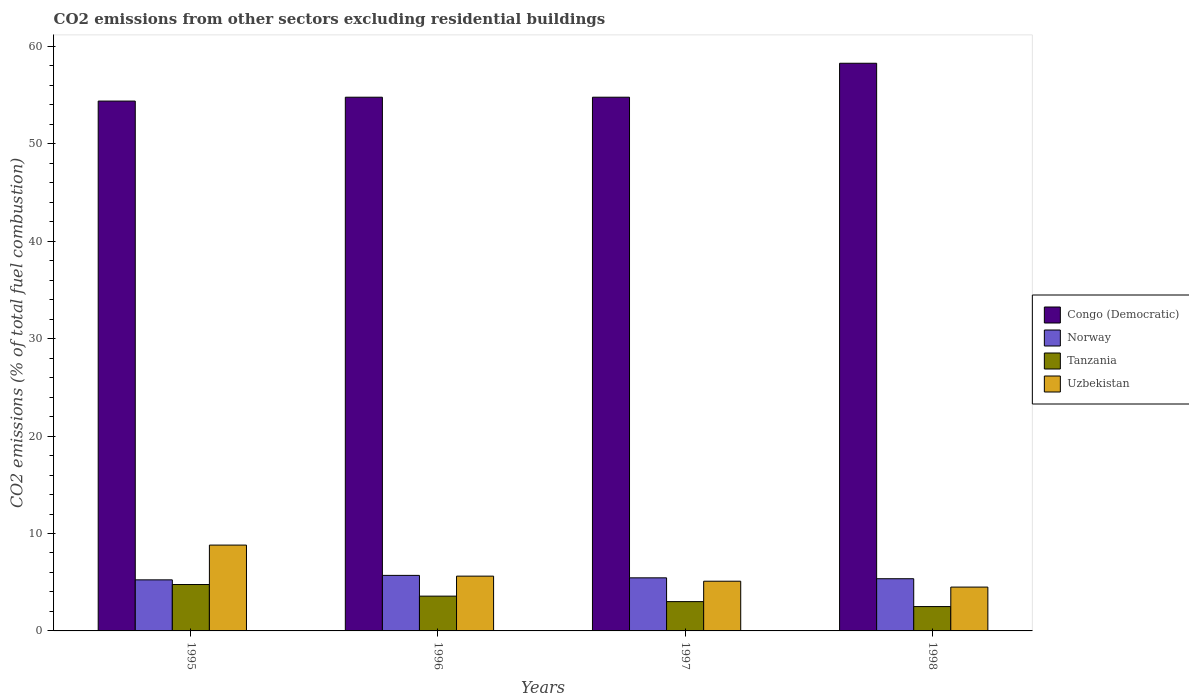How many different coloured bars are there?
Give a very brief answer. 4. How many groups of bars are there?
Give a very brief answer. 4. Are the number of bars per tick equal to the number of legend labels?
Make the answer very short. Yes. Are the number of bars on each tick of the X-axis equal?
Your answer should be compact. Yes. In how many cases, is the number of bars for a given year not equal to the number of legend labels?
Keep it short and to the point. 0. Across all years, what is the maximum total CO2 emitted in Congo (Democratic)?
Your answer should be very brief. 58.27. Across all years, what is the minimum total CO2 emitted in Congo (Democratic)?
Your response must be concise. 54.39. In which year was the total CO2 emitted in Norway minimum?
Make the answer very short. 1995. What is the total total CO2 emitted in Uzbekistan in the graph?
Offer a very short reply. 24.04. What is the difference between the total CO2 emitted in Congo (Democratic) in 1996 and that in 1998?
Offer a terse response. -3.49. What is the difference between the total CO2 emitted in Norway in 1997 and the total CO2 emitted in Uzbekistan in 1995?
Offer a very short reply. -3.36. What is the average total CO2 emitted in Tanzania per year?
Keep it short and to the point. 3.46. In the year 1995, what is the difference between the total CO2 emitted in Uzbekistan and total CO2 emitted in Norway?
Your answer should be very brief. 3.57. What is the ratio of the total CO2 emitted in Norway in 1995 to that in 1996?
Keep it short and to the point. 0.92. Is the total CO2 emitted in Norway in 1995 less than that in 1997?
Make the answer very short. Yes. Is the difference between the total CO2 emitted in Uzbekistan in 1996 and 1997 greater than the difference between the total CO2 emitted in Norway in 1996 and 1997?
Make the answer very short. Yes. What is the difference between the highest and the second highest total CO2 emitted in Tanzania?
Provide a succinct answer. 1.19. What is the difference between the highest and the lowest total CO2 emitted in Tanzania?
Provide a succinct answer. 2.26. In how many years, is the total CO2 emitted in Uzbekistan greater than the average total CO2 emitted in Uzbekistan taken over all years?
Keep it short and to the point. 1. What does the 4th bar from the left in 1997 represents?
Your response must be concise. Uzbekistan. What does the 1st bar from the right in 1998 represents?
Your response must be concise. Uzbekistan. How many bars are there?
Your answer should be very brief. 16. How many years are there in the graph?
Ensure brevity in your answer.  4. What is the difference between two consecutive major ticks on the Y-axis?
Keep it short and to the point. 10. Does the graph contain grids?
Give a very brief answer. No. How are the legend labels stacked?
Your answer should be very brief. Vertical. What is the title of the graph?
Offer a terse response. CO2 emissions from other sectors excluding residential buildings. Does "Comoros" appear as one of the legend labels in the graph?
Your response must be concise. No. What is the label or title of the X-axis?
Provide a succinct answer. Years. What is the label or title of the Y-axis?
Ensure brevity in your answer.  CO2 emissions (% of total fuel combustion). What is the CO2 emissions (% of total fuel combustion) of Congo (Democratic) in 1995?
Provide a succinct answer. 54.39. What is the CO2 emissions (% of total fuel combustion) in Norway in 1995?
Offer a terse response. 5.24. What is the CO2 emissions (% of total fuel combustion) in Tanzania in 1995?
Make the answer very short. 4.76. What is the CO2 emissions (% of total fuel combustion) of Uzbekistan in 1995?
Give a very brief answer. 8.81. What is the CO2 emissions (% of total fuel combustion) in Congo (Democratic) in 1996?
Ensure brevity in your answer.  54.78. What is the CO2 emissions (% of total fuel combustion) in Norway in 1996?
Make the answer very short. 5.7. What is the CO2 emissions (% of total fuel combustion) in Tanzania in 1996?
Provide a succinct answer. 3.57. What is the CO2 emissions (% of total fuel combustion) in Uzbekistan in 1996?
Your answer should be compact. 5.62. What is the CO2 emissions (% of total fuel combustion) in Congo (Democratic) in 1997?
Provide a succinct answer. 54.78. What is the CO2 emissions (% of total fuel combustion) in Norway in 1997?
Ensure brevity in your answer.  5.45. What is the CO2 emissions (% of total fuel combustion) in Tanzania in 1997?
Your response must be concise. 3.01. What is the CO2 emissions (% of total fuel combustion) in Uzbekistan in 1997?
Keep it short and to the point. 5.1. What is the CO2 emissions (% of total fuel combustion) of Congo (Democratic) in 1998?
Provide a succinct answer. 58.27. What is the CO2 emissions (% of total fuel combustion) of Norway in 1998?
Provide a short and direct response. 5.36. What is the CO2 emissions (% of total fuel combustion) in Tanzania in 1998?
Offer a very short reply. 2.5. What is the CO2 emissions (% of total fuel combustion) in Uzbekistan in 1998?
Your response must be concise. 4.5. Across all years, what is the maximum CO2 emissions (% of total fuel combustion) of Congo (Democratic)?
Give a very brief answer. 58.27. Across all years, what is the maximum CO2 emissions (% of total fuel combustion) in Norway?
Offer a terse response. 5.7. Across all years, what is the maximum CO2 emissions (% of total fuel combustion) of Tanzania?
Your answer should be compact. 4.76. Across all years, what is the maximum CO2 emissions (% of total fuel combustion) in Uzbekistan?
Your answer should be very brief. 8.81. Across all years, what is the minimum CO2 emissions (% of total fuel combustion) of Congo (Democratic)?
Offer a terse response. 54.39. Across all years, what is the minimum CO2 emissions (% of total fuel combustion) in Norway?
Keep it short and to the point. 5.24. Across all years, what is the minimum CO2 emissions (% of total fuel combustion) in Uzbekistan?
Offer a terse response. 4.5. What is the total CO2 emissions (% of total fuel combustion) of Congo (Democratic) in the graph?
Provide a short and direct response. 222.22. What is the total CO2 emissions (% of total fuel combustion) of Norway in the graph?
Make the answer very short. 21.75. What is the total CO2 emissions (% of total fuel combustion) of Tanzania in the graph?
Make the answer very short. 13.84. What is the total CO2 emissions (% of total fuel combustion) of Uzbekistan in the graph?
Make the answer very short. 24.04. What is the difference between the CO2 emissions (% of total fuel combustion) in Congo (Democratic) in 1995 and that in 1996?
Keep it short and to the point. -0.4. What is the difference between the CO2 emissions (% of total fuel combustion) in Norway in 1995 and that in 1996?
Keep it short and to the point. -0.46. What is the difference between the CO2 emissions (% of total fuel combustion) of Tanzania in 1995 and that in 1996?
Provide a short and direct response. 1.19. What is the difference between the CO2 emissions (% of total fuel combustion) in Uzbekistan in 1995 and that in 1996?
Make the answer very short. 3.19. What is the difference between the CO2 emissions (% of total fuel combustion) in Congo (Democratic) in 1995 and that in 1997?
Give a very brief answer. -0.4. What is the difference between the CO2 emissions (% of total fuel combustion) in Norway in 1995 and that in 1997?
Give a very brief answer. -0.21. What is the difference between the CO2 emissions (% of total fuel combustion) in Tanzania in 1995 and that in 1997?
Your response must be concise. 1.75. What is the difference between the CO2 emissions (% of total fuel combustion) of Uzbekistan in 1995 and that in 1997?
Ensure brevity in your answer.  3.71. What is the difference between the CO2 emissions (% of total fuel combustion) of Congo (Democratic) in 1995 and that in 1998?
Ensure brevity in your answer.  -3.88. What is the difference between the CO2 emissions (% of total fuel combustion) in Norway in 1995 and that in 1998?
Ensure brevity in your answer.  -0.11. What is the difference between the CO2 emissions (% of total fuel combustion) of Tanzania in 1995 and that in 1998?
Your response must be concise. 2.26. What is the difference between the CO2 emissions (% of total fuel combustion) of Uzbekistan in 1995 and that in 1998?
Offer a terse response. 4.31. What is the difference between the CO2 emissions (% of total fuel combustion) of Norway in 1996 and that in 1997?
Provide a short and direct response. 0.25. What is the difference between the CO2 emissions (% of total fuel combustion) in Tanzania in 1996 and that in 1997?
Provide a succinct answer. 0.56. What is the difference between the CO2 emissions (% of total fuel combustion) of Uzbekistan in 1996 and that in 1997?
Offer a terse response. 0.52. What is the difference between the CO2 emissions (% of total fuel combustion) in Congo (Democratic) in 1996 and that in 1998?
Give a very brief answer. -3.49. What is the difference between the CO2 emissions (% of total fuel combustion) in Norway in 1996 and that in 1998?
Your answer should be very brief. 0.34. What is the difference between the CO2 emissions (% of total fuel combustion) of Tanzania in 1996 and that in 1998?
Provide a succinct answer. 1.07. What is the difference between the CO2 emissions (% of total fuel combustion) of Uzbekistan in 1996 and that in 1998?
Your answer should be compact. 1.12. What is the difference between the CO2 emissions (% of total fuel combustion) of Congo (Democratic) in 1997 and that in 1998?
Make the answer very short. -3.49. What is the difference between the CO2 emissions (% of total fuel combustion) in Norway in 1997 and that in 1998?
Make the answer very short. 0.09. What is the difference between the CO2 emissions (% of total fuel combustion) in Tanzania in 1997 and that in 1998?
Ensure brevity in your answer.  0.51. What is the difference between the CO2 emissions (% of total fuel combustion) in Uzbekistan in 1997 and that in 1998?
Offer a terse response. 0.6. What is the difference between the CO2 emissions (% of total fuel combustion) in Congo (Democratic) in 1995 and the CO2 emissions (% of total fuel combustion) in Norway in 1996?
Keep it short and to the point. 48.68. What is the difference between the CO2 emissions (% of total fuel combustion) in Congo (Democratic) in 1995 and the CO2 emissions (% of total fuel combustion) in Tanzania in 1996?
Your answer should be very brief. 50.81. What is the difference between the CO2 emissions (% of total fuel combustion) in Congo (Democratic) in 1995 and the CO2 emissions (% of total fuel combustion) in Uzbekistan in 1996?
Provide a short and direct response. 48.76. What is the difference between the CO2 emissions (% of total fuel combustion) in Norway in 1995 and the CO2 emissions (% of total fuel combustion) in Tanzania in 1996?
Provide a short and direct response. 1.67. What is the difference between the CO2 emissions (% of total fuel combustion) in Norway in 1995 and the CO2 emissions (% of total fuel combustion) in Uzbekistan in 1996?
Your response must be concise. -0.38. What is the difference between the CO2 emissions (% of total fuel combustion) in Tanzania in 1995 and the CO2 emissions (% of total fuel combustion) in Uzbekistan in 1996?
Your answer should be compact. -0.86. What is the difference between the CO2 emissions (% of total fuel combustion) in Congo (Democratic) in 1995 and the CO2 emissions (% of total fuel combustion) in Norway in 1997?
Make the answer very short. 48.94. What is the difference between the CO2 emissions (% of total fuel combustion) in Congo (Democratic) in 1995 and the CO2 emissions (% of total fuel combustion) in Tanzania in 1997?
Offer a terse response. 51.38. What is the difference between the CO2 emissions (% of total fuel combustion) of Congo (Democratic) in 1995 and the CO2 emissions (% of total fuel combustion) of Uzbekistan in 1997?
Provide a succinct answer. 49.28. What is the difference between the CO2 emissions (% of total fuel combustion) in Norway in 1995 and the CO2 emissions (% of total fuel combustion) in Tanzania in 1997?
Provide a short and direct response. 2.23. What is the difference between the CO2 emissions (% of total fuel combustion) of Norway in 1995 and the CO2 emissions (% of total fuel combustion) of Uzbekistan in 1997?
Your answer should be very brief. 0.14. What is the difference between the CO2 emissions (% of total fuel combustion) of Tanzania in 1995 and the CO2 emissions (% of total fuel combustion) of Uzbekistan in 1997?
Ensure brevity in your answer.  -0.34. What is the difference between the CO2 emissions (% of total fuel combustion) in Congo (Democratic) in 1995 and the CO2 emissions (% of total fuel combustion) in Norway in 1998?
Keep it short and to the point. 49.03. What is the difference between the CO2 emissions (% of total fuel combustion) in Congo (Democratic) in 1995 and the CO2 emissions (% of total fuel combustion) in Tanzania in 1998?
Offer a terse response. 51.89. What is the difference between the CO2 emissions (% of total fuel combustion) of Congo (Democratic) in 1995 and the CO2 emissions (% of total fuel combustion) of Uzbekistan in 1998?
Ensure brevity in your answer.  49.89. What is the difference between the CO2 emissions (% of total fuel combustion) in Norway in 1995 and the CO2 emissions (% of total fuel combustion) in Tanzania in 1998?
Your answer should be compact. 2.74. What is the difference between the CO2 emissions (% of total fuel combustion) of Norway in 1995 and the CO2 emissions (% of total fuel combustion) of Uzbekistan in 1998?
Make the answer very short. 0.74. What is the difference between the CO2 emissions (% of total fuel combustion) in Tanzania in 1995 and the CO2 emissions (% of total fuel combustion) in Uzbekistan in 1998?
Your answer should be compact. 0.26. What is the difference between the CO2 emissions (% of total fuel combustion) of Congo (Democratic) in 1996 and the CO2 emissions (% of total fuel combustion) of Norway in 1997?
Provide a succinct answer. 49.33. What is the difference between the CO2 emissions (% of total fuel combustion) in Congo (Democratic) in 1996 and the CO2 emissions (% of total fuel combustion) in Tanzania in 1997?
Provide a succinct answer. 51.78. What is the difference between the CO2 emissions (% of total fuel combustion) in Congo (Democratic) in 1996 and the CO2 emissions (% of total fuel combustion) in Uzbekistan in 1997?
Ensure brevity in your answer.  49.68. What is the difference between the CO2 emissions (% of total fuel combustion) in Norway in 1996 and the CO2 emissions (% of total fuel combustion) in Tanzania in 1997?
Give a very brief answer. 2.69. What is the difference between the CO2 emissions (% of total fuel combustion) of Norway in 1996 and the CO2 emissions (% of total fuel combustion) of Uzbekistan in 1997?
Keep it short and to the point. 0.6. What is the difference between the CO2 emissions (% of total fuel combustion) of Tanzania in 1996 and the CO2 emissions (% of total fuel combustion) of Uzbekistan in 1997?
Your answer should be very brief. -1.53. What is the difference between the CO2 emissions (% of total fuel combustion) in Congo (Democratic) in 1996 and the CO2 emissions (% of total fuel combustion) in Norway in 1998?
Your answer should be very brief. 49.43. What is the difference between the CO2 emissions (% of total fuel combustion) in Congo (Democratic) in 1996 and the CO2 emissions (% of total fuel combustion) in Tanzania in 1998?
Make the answer very short. 52.28. What is the difference between the CO2 emissions (% of total fuel combustion) in Congo (Democratic) in 1996 and the CO2 emissions (% of total fuel combustion) in Uzbekistan in 1998?
Make the answer very short. 50.28. What is the difference between the CO2 emissions (% of total fuel combustion) in Norway in 1996 and the CO2 emissions (% of total fuel combustion) in Tanzania in 1998?
Your response must be concise. 3.2. What is the difference between the CO2 emissions (% of total fuel combustion) of Norway in 1996 and the CO2 emissions (% of total fuel combustion) of Uzbekistan in 1998?
Offer a very short reply. 1.2. What is the difference between the CO2 emissions (% of total fuel combustion) of Tanzania in 1996 and the CO2 emissions (% of total fuel combustion) of Uzbekistan in 1998?
Your answer should be very brief. -0.93. What is the difference between the CO2 emissions (% of total fuel combustion) in Congo (Democratic) in 1997 and the CO2 emissions (% of total fuel combustion) in Norway in 1998?
Offer a terse response. 49.43. What is the difference between the CO2 emissions (% of total fuel combustion) of Congo (Democratic) in 1997 and the CO2 emissions (% of total fuel combustion) of Tanzania in 1998?
Offer a very short reply. 52.28. What is the difference between the CO2 emissions (% of total fuel combustion) of Congo (Democratic) in 1997 and the CO2 emissions (% of total fuel combustion) of Uzbekistan in 1998?
Keep it short and to the point. 50.28. What is the difference between the CO2 emissions (% of total fuel combustion) of Norway in 1997 and the CO2 emissions (% of total fuel combustion) of Tanzania in 1998?
Provide a succinct answer. 2.95. What is the difference between the CO2 emissions (% of total fuel combustion) of Norway in 1997 and the CO2 emissions (% of total fuel combustion) of Uzbekistan in 1998?
Provide a succinct answer. 0.95. What is the difference between the CO2 emissions (% of total fuel combustion) of Tanzania in 1997 and the CO2 emissions (% of total fuel combustion) of Uzbekistan in 1998?
Your answer should be compact. -1.49. What is the average CO2 emissions (% of total fuel combustion) of Congo (Democratic) per year?
Ensure brevity in your answer.  55.55. What is the average CO2 emissions (% of total fuel combustion) of Norway per year?
Provide a succinct answer. 5.44. What is the average CO2 emissions (% of total fuel combustion) in Tanzania per year?
Give a very brief answer. 3.46. What is the average CO2 emissions (% of total fuel combustion) in Uzbekistan per year?
Your answer should be compact. 6.01. In the year 1995, what is the difference between the CO2 emissions (% of total fuel combustion) in Congo (Democratic) and CO2 emissions (% of total fuel combustion) in Norway?
Give a very brief answer. 49.14. In the year 1995, what is the difference between the CO2 emissions (% of total fuel combustion) of Congo (Democratic) and CO2 emissions (% of total fuel combustion) of Tanzania?
Ensure brevity in your answer.  49.62. In the year 1995, what is the difference between the CO2 emissions (% of total fuel combustion) of Congo (Democratic) and CO2 emissions (% of total fuel combustion) of Uzbekistan?
Ensure brevity in your answer.  45.58. In the year 1995, what is the difference between the CO2 emissions (% of total fuel combustion) in Norway and CO2 emissions (% of total fuel combustion) in Tanzania?
Give a very brief answer. 0.48. In the year 1995, what is the difference between the CO2 emissions (% of total fuel combustion) of Norway and CO2 emissions (% of total fuel combustion) of Uzbekistan?
Your answer should be compact. -3.57. In the year 1995, what is the difference between the CO2 emissions (% of total fuel combustion) in Tanzania and CO2 emissions (% of total fuel combustion) in Uzbekistan?
Provide a succinct answer. -4.05. In the year 1996, what is the difference between the CO2 emissions (% of total fuel combustion) of Congo (Democratic) and CO2 emissions (% of total fuel combustion) of Norway?
Offer a terse response. 49.08. In the year 1996, what is the difference between the CO2 emissions (% of total fuel combustion) in Congo (Democratic) and CO2 emissions (% of total fuel combustion) in Tanzania?
Provide a succinct answer. 51.21. In the year 1996, what is the difference between the CO2 emissions (% of total fuel combustion) in Congo (Democratic) and CO2 emissions (% of total fuel combustion) in Uzbekistan?
Keep it short and to the point. 49.16. In the year 1996, what is the difference between the CO2 emissions (% of total fuel combustion) of Norway and CO2 emissions (% of total fuel combustion) of Tanzania?
Offer a terse response. 2.13. In the year 1996, what is the difference between the CO2 emissions (% of total fuel combustion) of Norway and CO2 emissions (% of total fuel combustion) of Uzbekistan?
Offer a very short reply. 0.08. In the year 1996, what is the difference between the CO2 emissions (% of total fuel combustion) in Tanzania and CO2 emissions (% of total fuel combustion) in Uzbekistan?
Ensure brevity in your answer.  -2.05. In the year 1997, what is the difference between the CO2 emissions (% of total fuel combustion) in Congo (Democratic) and CO2 emissions (% of total fuel combustion) in Norway?
Offer a terse response. 49.33. In the year 1997, what is the difference between the CO2 emissions (% of total fuel combustion) of Congo (Democratic) and CO2 emissions (% of total fuel combustion) of Tanzania?
Offer a terse response. 51.78. In the year 1997, what is the difference between the CO2 emissions (% of total fuel combustion) of Congo (Democratic) and CO2 emissions (% of total fuel combustion) of Uzbekistan?
Ensure brevity in your answer.  49.68. In the year 1997, what is the difference between the CO2 emissions (% of total fuel combustion) of Norway and CO2 emissions (% of total fuel combustion) of Tanzania?
Offer a terse response. 2.44. In the year 1997, what is the difference between the CO2 emissions (% of total fuel combustion) of Norway and CO2 emissions (% of total fuel combustion) of Uzbekistan?
Your answer should be very brief. 0.35. In the year 1997, what is the difference between the CO2 emissions (% of total fuel combustion) in Tanzania and CO2 emissions (% of total fuel combustion) in Uzbekistan?
Offer a terse response. -2.09. In the year 1998, what is the difference between the CO2 emissions (% of total fuel combustion) in Congo (Democratic) and CO2 emissions (% of total fuel combustion) in Norway?
Provide a short and direct response. 52.91. In the year 1998, what is the difference between the CO2 emissions (% of total fuel combustion) in Congo (Democratic) and CO2 emissions (% of total fuel combustion) in Tanzania?
Give a very brief answer. 55.77. In the year 1998, what is the difference between the CO2 emissions (% of total fuel combustion) of Congo (Democratic) and CO2 emissions (% of total fuel combustion) of Uzbekistan?
Make the answer very short. 53.77. In the year 1998, what is the difference between the CO2 emissions (% of total fuel combustion) in Norway and CO2 emissions (% of total fuel combustion) in Tanzania?
Offer a terse response. 2.86. In the year 1998, what is the difference between the CO2 emissions (% of total fuel combustion) of Norway and CO2 emissions (% of total fuel combustion) of Uzbekistan?
Make the answer very short. 0.86. In the year 1998, what is the difference between the CO2 emissions (% of total fuel combustion) in Tanzania and CO2 emissions (% of total fuel combustion) in Uzbekistan?
Provide a short and direct response. -2. What is the ratio of the CO2 emissions (% of total fuel combustion) of Congo (Democratic) in 1995 to that in 1996?
Offer a terse response. 0.99. What is the ratio of the CO2 emissions (% of total fuel combustion) in Norway in 1995 to that in 1996?
Give a very brief answer. 0.92. What is the ratio of the CO2 emissions (% of total fuel combustion) of Tanzania in 1995 to that in 1996?
Your response must be concise. 1.33. What is the ratio of the CO2 emissions (% of total fuel combustion) in Uzbekistan in 1995 to that in 1996?
Your answer should be compact. 1.57. What is the ratio of the CO2 emissions (% of total fuel combustion) in Norway in 1995 to that in 1997?
Your response must be concise. 0.96. What is the ratio of the CO2 emissions (% of total fuel combustion) in Tanzania in 1995 to that in 1997?
Ensure brevity in your answer.  1.58. What is the ratio of the CO2 emissions (% of total fuel combustion) of Uzbekistan in 1995 to that in 1997?
Keep it short and to the point. 1.73. What is the ratio of the CO2 emissions (% of total fuel combustion) in Congo (Democratic) in 1995 to that in 1998?
Provide a succinct answer. 0.93. What is the ratio of the CO2 emissions (% of total fuel combustion) of Norway in 1995 to that in 1998?
Provide a succinct answer. 0.98. What is the ratio of the CO2 emissions (% of total fuel combustion) in Tanzania in 1995 to that in 1998?
Offer a terse response. 1.9. What is the ratio of the CO2 emissions (% of total fuel combustion) in Uzbekistan in 1995 to that in 1998?
Your answer should be very brief. 1.96. What is the ratio of the CO2 emissions (% of total fuel combustion) in Congo (Democratic) in 1996 to that in 1997?
Your answer should be compact. 1. What is the ratio of the CO2 emissions (% of total fuel combustion) of Norway in 1996 to that in 1997?
Give a very brief answer. 1.05. What is the ratio of the CO2 emissions (% of total fuel combustion) of Tanzania in 1996 to that in 1997?
Offer a very short reply. 1.19. What is the ratio of the CO2 emissions (% of total fuel combustion) of Uzbekistan in 1996 to that in 1997?
Offer a very short reply. 1.1. What is the ratio of the CO2 emissions (% of total fuel combustion) of Congo (Democratic) in 1996 to that in 1998?
Ensure brevity in your answer.  0.94. What is the ratio of the CO2 emissions (% of total fuel combustion) of Norway in 1996 to that in 1998?
Provide a short and direct response. 1.06. What is the ratio of the CO2 emissions (% of total fuel combustion) of Tanzania in 1996 to that in 1998?
Make the answer very short. 1.43. What is the ratio of the CO2 emissions (% of total fuel combustion) in Uzbekistan in 1996 to that in 1998?
Give a very brief answer. 1.25. What is the ratio of the CO2 emissions (% of total fuel combustion) in Congo (Democratic) in 1997 to that in 1998?
Provide a succinct answer. 0.94. What is the ratio of the CO2 emissions (% of total fuel combustion) in Tanzania in 1997 to that in 1998?
Provide a short and direct response. 1.2. What is the ratio of the CO2 emissions (% of total fuel combustion) of Uzbekistan in 1997 to that in 1998?
Offer a terse response. 1.13. What is the difference between the highest and the second highest CO2 emissions (% of total fuel combustion) in Congo (Democratic)?
Offer a terse response. 3.49. What is the difference between the highest and the second highest CO2 emissions (% of total fuel combustion) in Norway?
Provide a succinct answer. 0.25. What is the difference between the highest and the second highest CO2 emissions (% of total fuel combustion) of Tanzania?
Offer a very short reply. 1.19. What is the difference between the highest and the second highest CO2 emissions (% of total fuel combustion) of Uzbekistan?
Your answer should be very brief. 3.19. What is the difference between the highest and the lowest CO2 emissions (% of total fuel combustion) of Congo (Democratic)?
Give a very brief answer. 3.88. What is the difference between the highest and the lowest CO2 emissions (% of total fuel combustion) of Norway?
Offer a terse response. 0.46. What is the difference between the highest and the lowest CO2 emissions (% of total fuel combustion) of Tanzania?
Make the answer very short. 2.26. What is the difference between the highest and the lowest CO2 emissions (% of total fuel combustion) in Uzbekistan?
Provide a short and direct response. 4.31. 